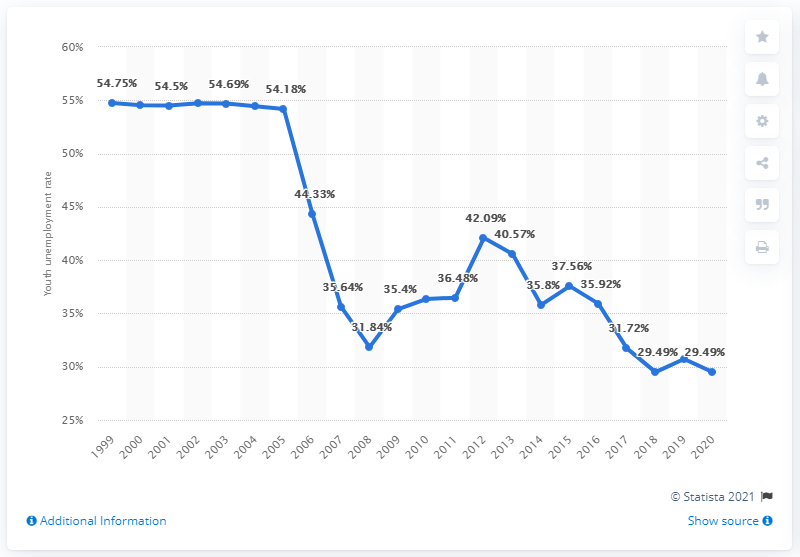Give some essential details in this illustration. The youth unemployment rate in Montenegro was 29.49% in 2020. 